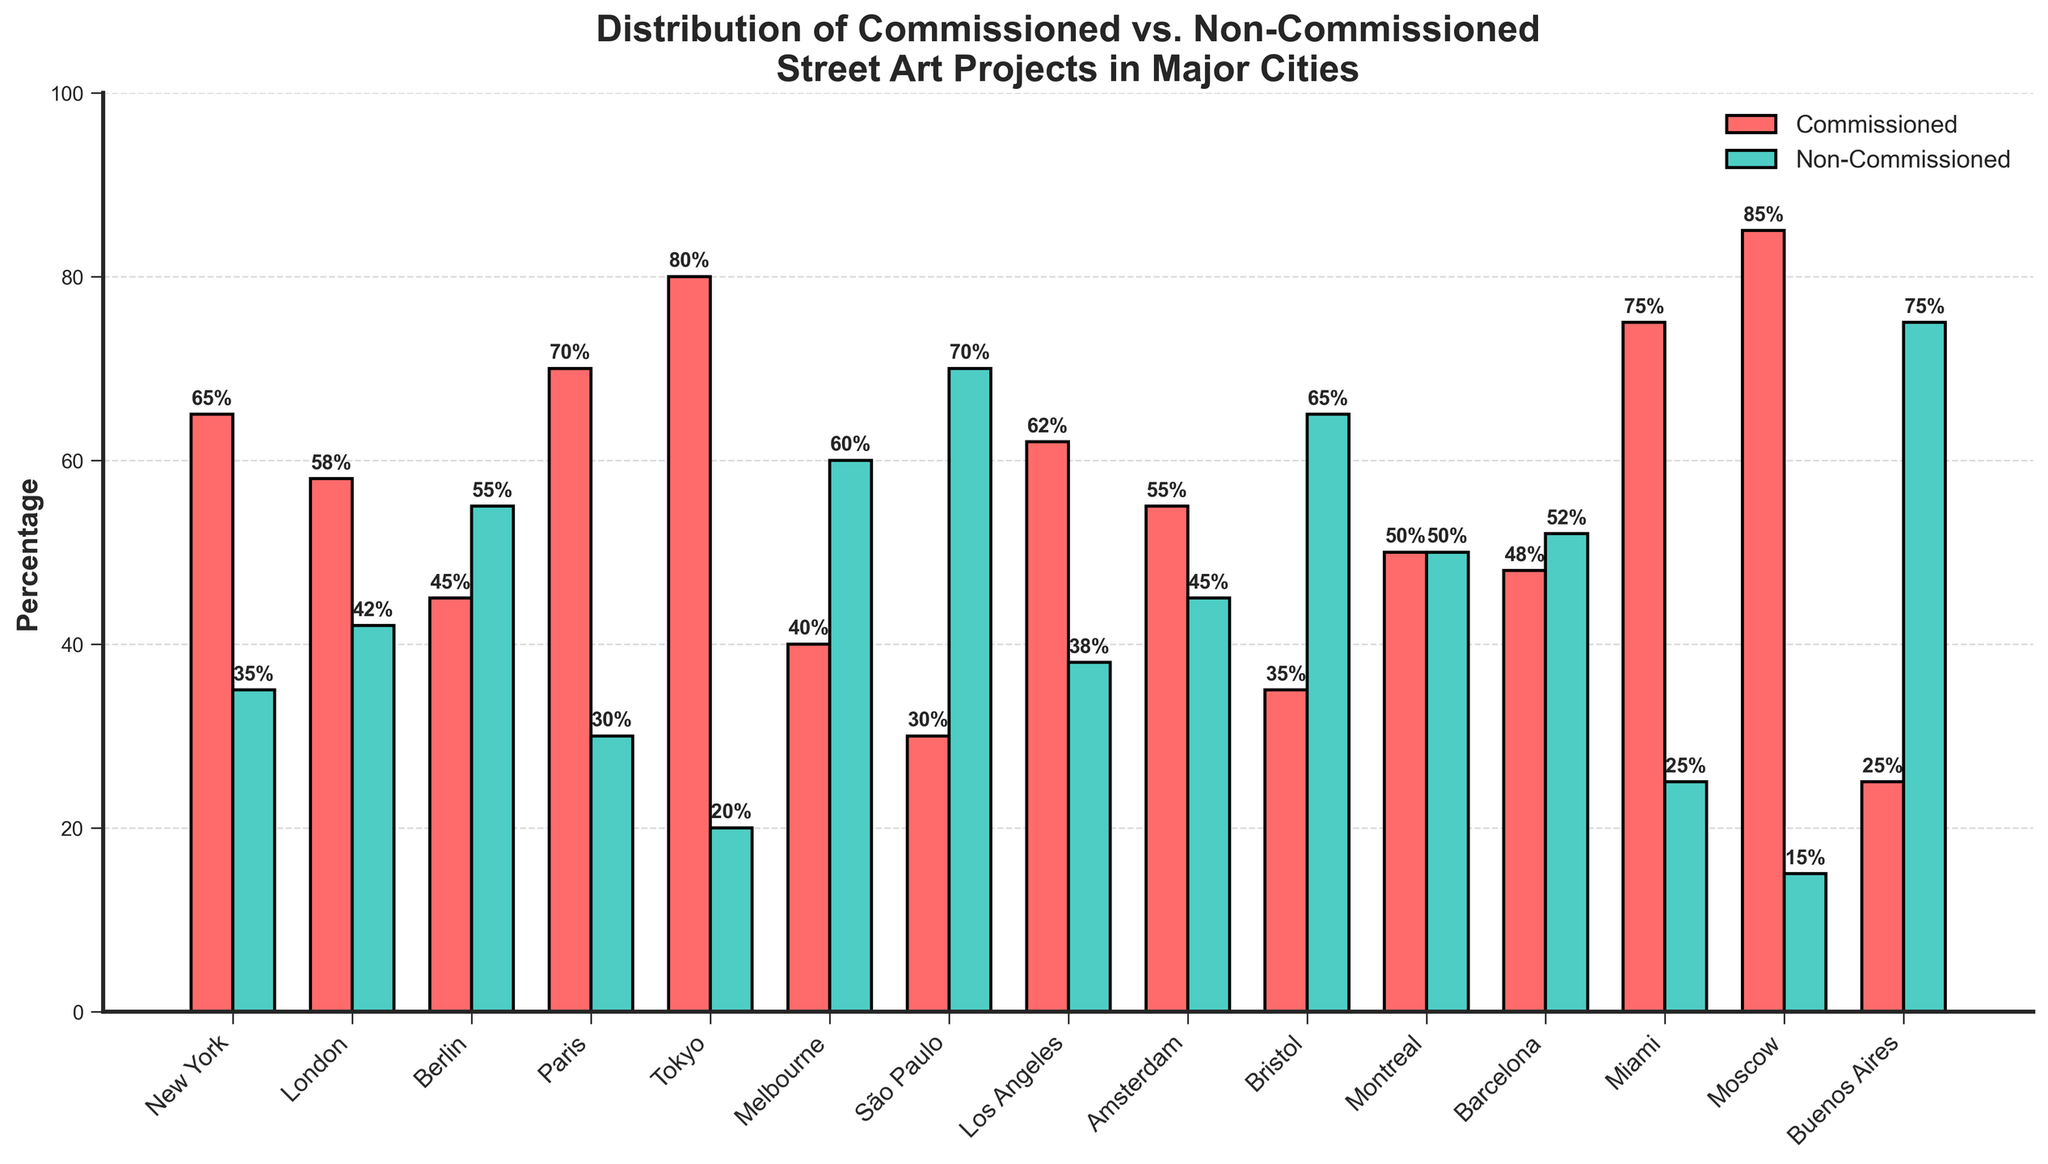What city has the highest percentage of commissioned street art projects? First, identify the bar with the tallest height in the group labeled "Commissioned". Moscow's bar reaches the highest point at 85%.
Answer: Moscow Which city has a higher percentage of non-commissioned street art, Berlin or Melbourne? Locate the bars corresponding to "Non-Commissioned" for both Berlin and Melbourne. Berlin has 55% and Melbourne has 60%. Compare these values, noting that 60% is greater than 55%.
Answer: Melbourne What's the difference in the percentage of commissioned street art projects between New York and São Paulo? Identify the heights of the "Commissioned" bars for New York (65%) and São Paulo (30%). Subtract 30 from 65: 65 - 30 = 35.
Answer: 35 What is the combined percentage of commissioned and non-commissioned street art in Paris? Identify the heights of both the "Commissioned" (70%) and "Non-Commissioned" (30%) bars for Paris. Sum these percentages: 70 + 30 = 100.
Answer: 100 In which city is the percentage of commissioned street art projects equal to the percentage of non-commissioned street art projects? Identify the city whose "Commissioned" and "Non-Commissioned" bars are equal in height. This occurs in Montreal, where both percentages are 50%.
Answer: Montreal Which city has the smallest percentage of commissioned street art projects? Identify the shortest "Commissioned" bar. Buenos Aires has the smallest percentage at 25%.
Answer: Buenos Aires Compare the percentage of commissioned street art projects in Tokyo and Miami. Which city has more? Identify the heights of the "Commissioned" bars for Tokyo (80%) and Miami (75%). Tokyo's bar is higher.
Answer: Tokyo What's the average percentage of non-commissioned street art projects in Berlin, Amsterdam, and Barcelona? Identify the heights of the "Non-Commissioned" bars for Berlin (55%), Amsterdam (45%), and Barcelona (52%). Sum these values: 55 + 45 + 52 = 152. Divide by 3 to find the average: 152 / 3 ≈ 50.67.
Answer: 50.67 Which two cities have the most even distribution of commissioned and non-commissioned street art projects? Look for cities where the heights of the "Commissioned" and "Non-Commissioned" bars are most similar. Montreal (both at 50%) and Barcelona (48% commissioned, 52% non-commissioned) have the most even distribution.
Answer: Montreal, Barcelona What is the total percentage of commissioned street art projects in New York, Los Angeles, and London? Identify the heights of the "Commissioned" bars for New York (65%), Los Angeles (62%), and London (58%). Sum these percentages: 65 + 62 + 58 = 185.
Answer: 185 